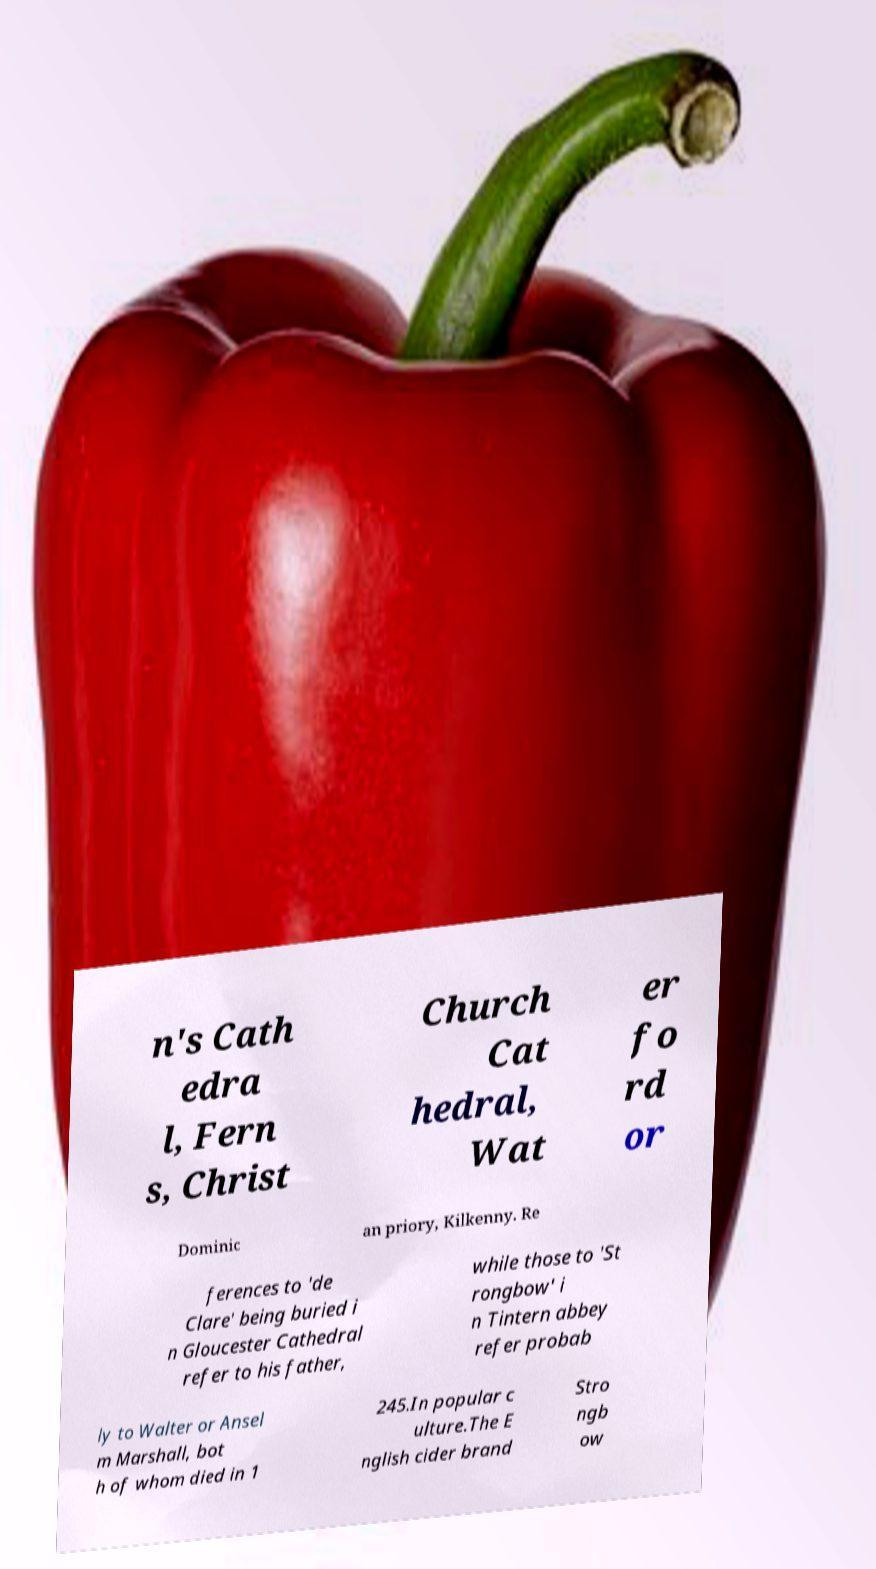For documentation purposes, I need the text within this image transcribed. Could you provide that? n's Cath edra l, Fern s, Christ Church Cat hedral, Wat er fo rd or Dominic an priory, Kilkenny. Re ferences to 'de Clare' being buried i n Gloucester Cathedral refer to his father, while those to 'St rongbow' i n Tintern abbey refer probab ly to Walter or Ansel m Marshall, bot h of whom died in 1 245.In popular c ulture.The E nglish cider brand Stro ngb ow 